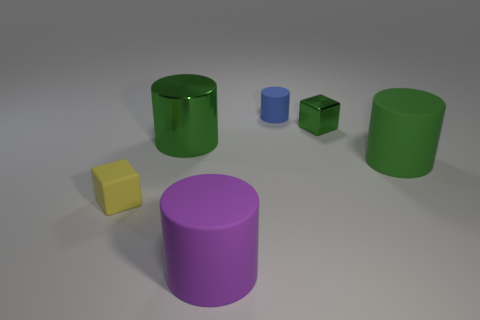Is there a large metallic thing that has the same color as the small shiny cube?
Your answer should be very brief. Yes. What size is the object that is behind the cube right of the small thing in front of the big metallic cylinder?
Ensure brevity in your answer.  Small. Does the tiny metal thing have the same shape as the tiny rubber thing that is in front of the tiny shiny block?
Provide a short and direct response. Yes. What number of other objects are there of the same size as the purple cylinder?
Make the answer very short. 2. What is the size of the shiny object that is left of the tiny green thing?
Give a very brief answer. Large. What number of tiny blue things have the same material as the small cylinder?
Offer a terse response. 0. Is the shape of the shiny thing left of the purple rubber cylinder the same as  the blue object?
Give a very brief answer. Yes. What is the shape of the big thing that is in front of the yellow thing?
Offer a very short reply. Cylinder. There is a metal thing that is the same color as the large metallic cylinder; what is its size?
Your answer should be very brief. Small. What is the tiny green cube made of?
Keep it short and to the point. Metal. 